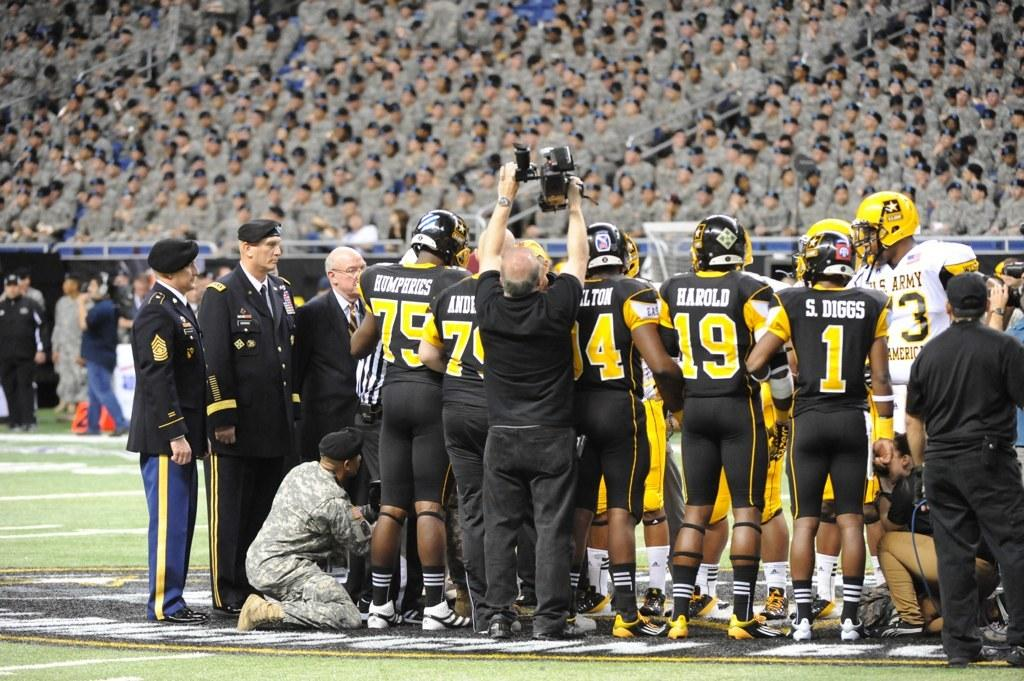Where are the spectators located in the image? The spectators are at the top of the image. What are the people at the bottom of the image doing? The people at the bottom of the image are standing on the ground. Can you identify any specific object or action being performed by one of the individuals in the image? Yes, one person is holding a camera in their hands. What color is the curtain behind the person holding the camera in the image? There is no curtain present in the image. How does the stomach of the person holding the camera feel in the image? The image does not provide information about the person's feelings or physical sensations, including their stomach. 